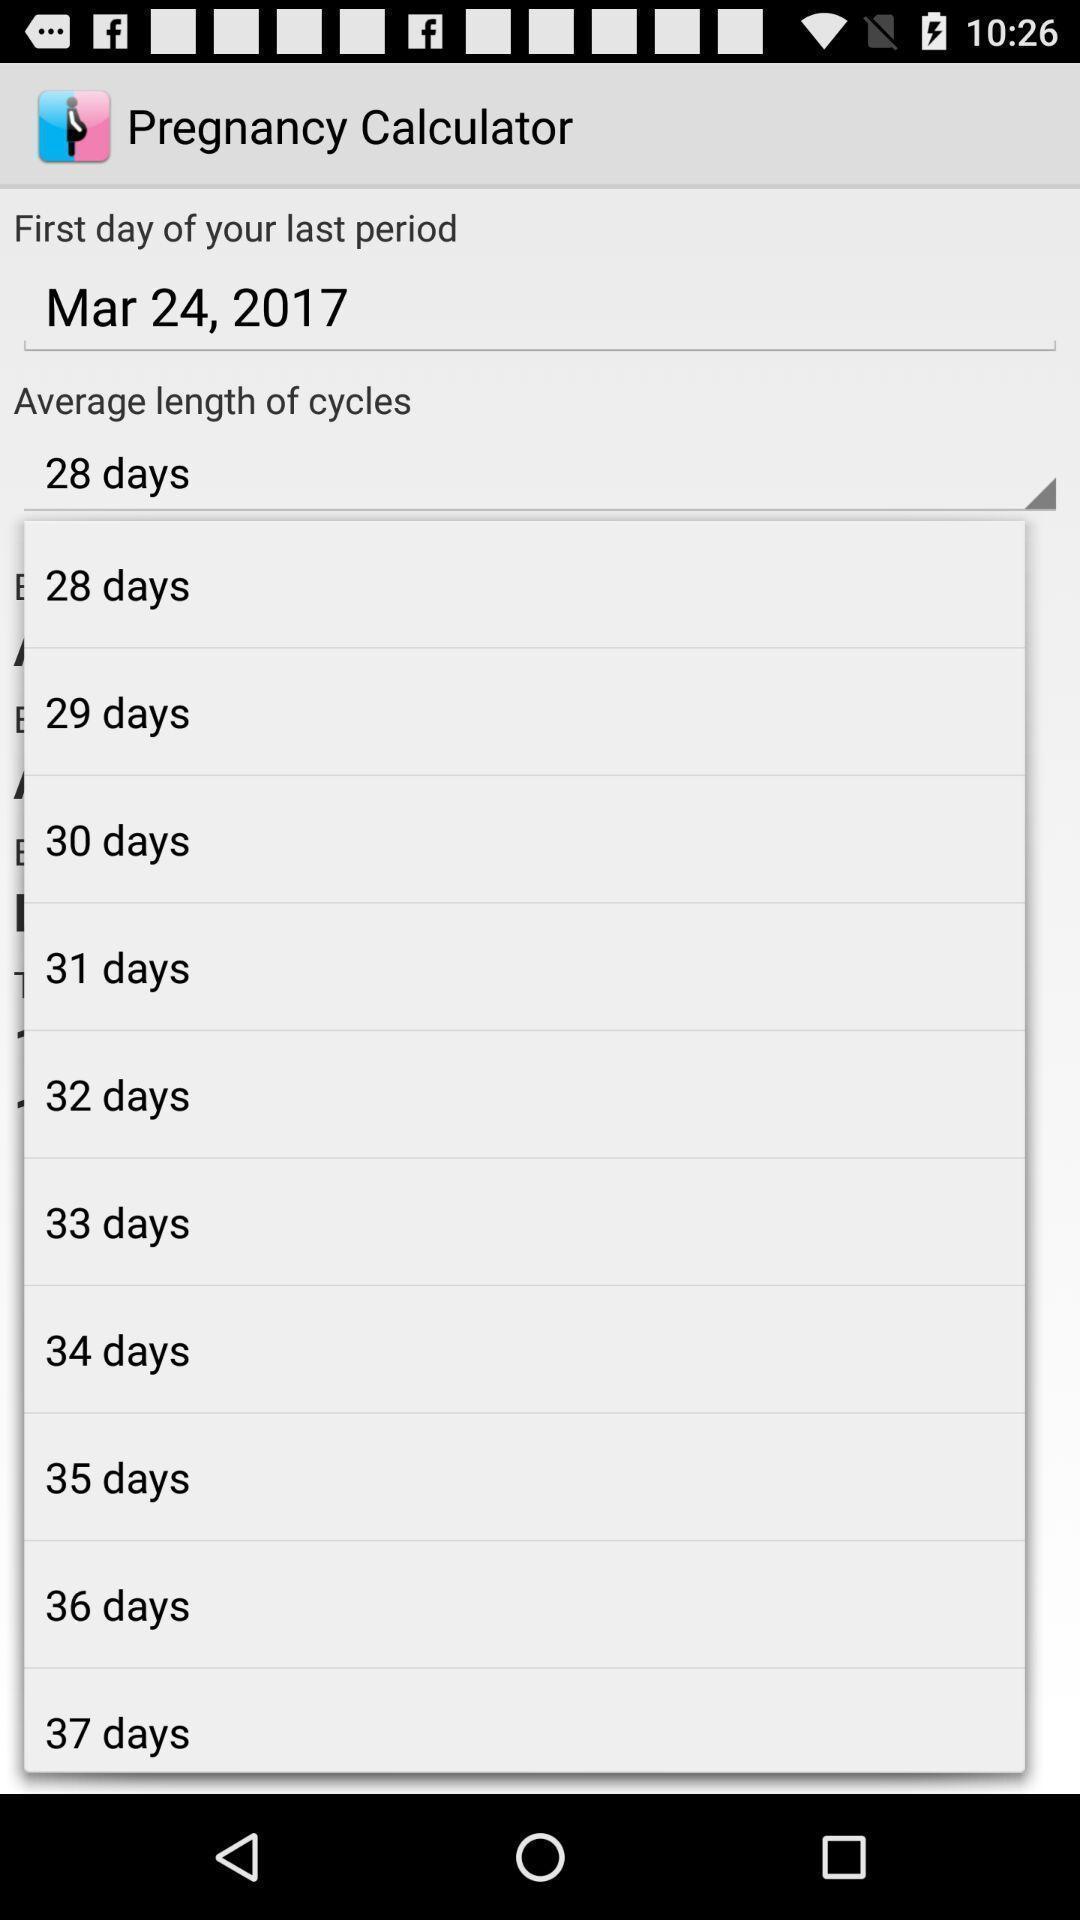What is the overall content of this screenshot? List of days in a ladies calculator of pregnancy app. 